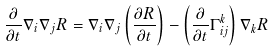<formula> <loc_0><loc_0><loc_500><loc_500>\frac { \partial } { \partial t } \nabla _ { i } \nabla _ { j } R = \nabla _ { i } \nabla _ { j } \left ( \frac { \partial R } { \partial t } \right ) - \left ( \frac { \partial } { \partial t } \Gamma ^ { k } _ { i j } \right ) \nabla _ { k } R</formula> 